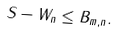Convert formula to latex. <formula><loc_0><loc_0><loc_500><loc_500>\| S - W _ { n } \| \leq B _ { m , n } .</formula> 